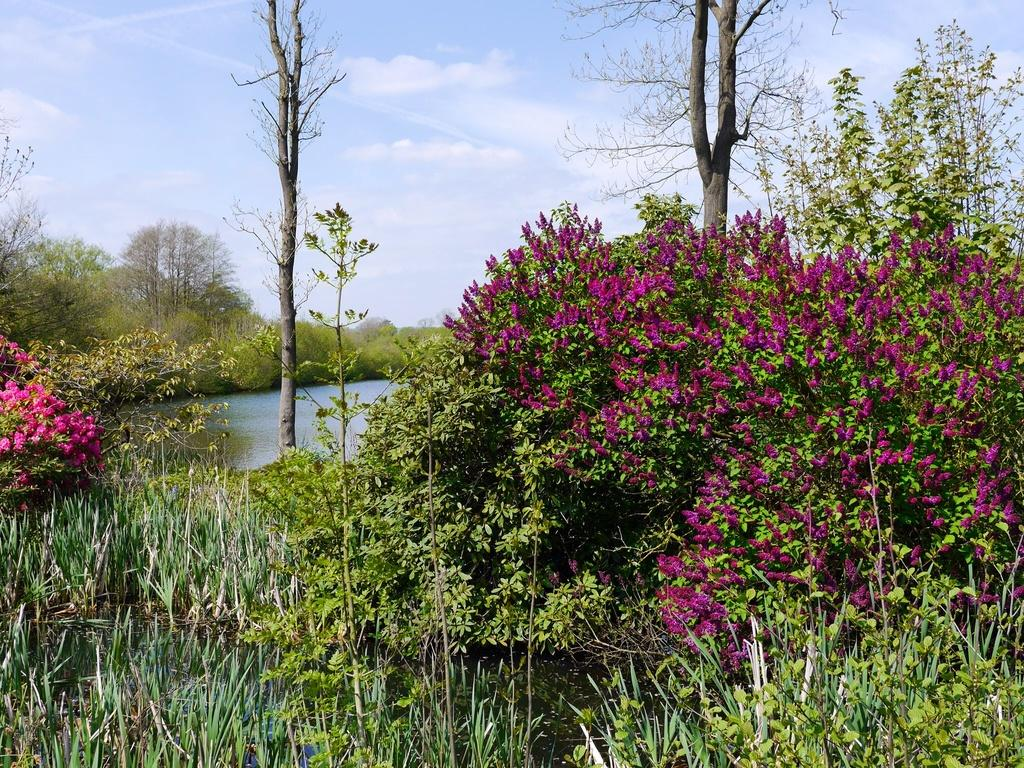What type of vegetation can be seen in the image? There is grass and plants with flowers in the image. What else is visible in the image besides vegetation? There is water and trees visible in the image. What can be seen in the background of the image? The sky is visible in the background of the image. Who is the owner of the quilt in the image? There is no quilt present in the image, so it is not possible to determine the owner. Can you tell me how many bees are buzzing around the flowers in the image? There are no bees visible in the image; it only features plants with flowers. 